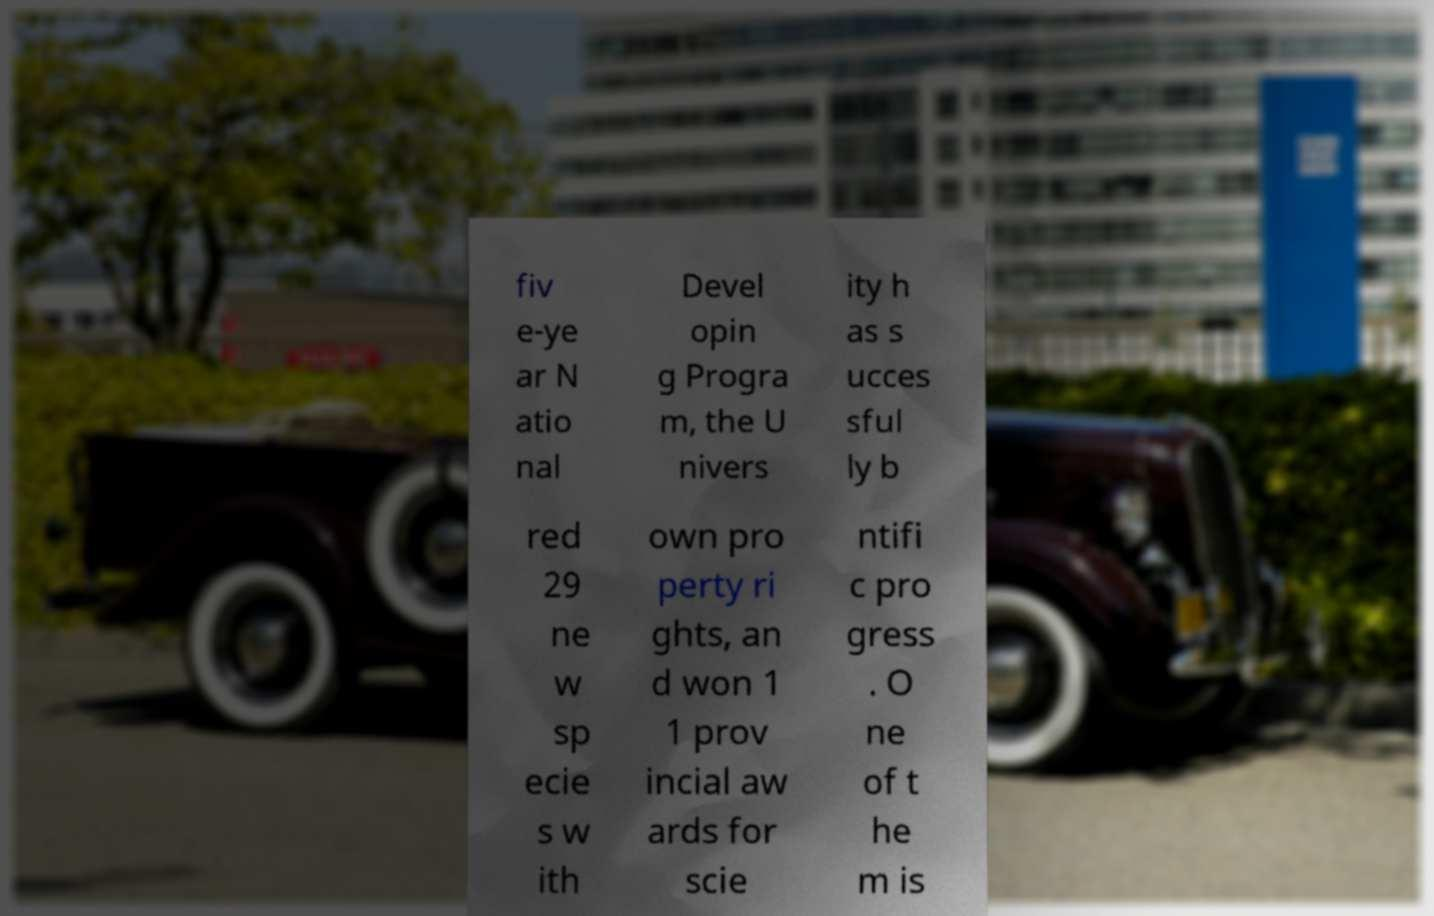I need the written content from this picture converted into text. Can you do that? fiv e-ye ar N atio nal Devel opin g Progra m, the U nivers ity h as s ucces sful ly b red 29 ne w sp ecie s w ith own pro perty ri ghts, an d won 1 1 prov incial aw ards for scie ntifi c pro gress . O ne of t he m is 